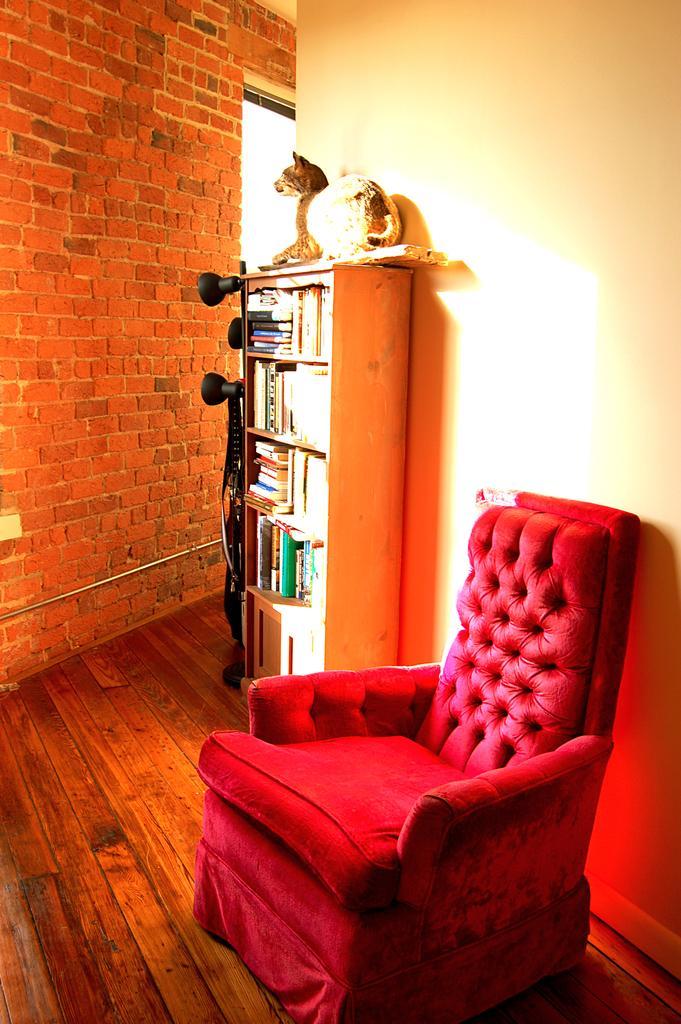Can you describe this image briefly? In this image in the front there is a sofa which is red in colour and in the center there is a shelf and on the top of the shelf there is toy and in the shelf there are books and there is an object which is black in colour and there is a wall which is red in colour. 